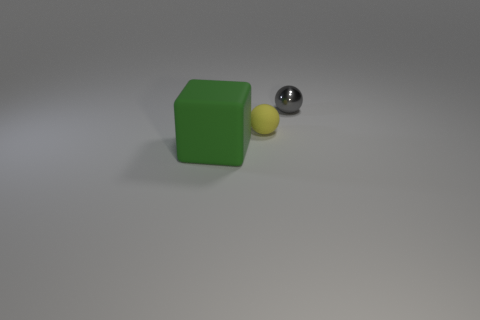The other object that is the same material as the small yellow thing is what size?
Your answer should be very brief. Large. There is a object that is behind the big green thing and left of the tiny gray ball; what shape is it?
Your answer should be compact. Sphere. There is a large rubber block; are there any gray metallic things right of it?
Your answer should be very brief. Yes. Are there any other things that have the same size as the block?
Your response must be concise. No. Is the small yellow object the same shape as the small gray metal object?
Offer a terse response. Yes. What is the size of the matte block left of the thing that is right of the rubber sphere?
Keep it short and to the point. Large. What color is the tiny shiny object that is the same shape as the small matte thing?
Keep it short and to the point. Gray. What number of big matte objects are the same color as the metal thing?
Your answer should be compact. 0. The metal sphere is what size?
Provide a short and direct response. Small. Do the yellow matte object and the metallic object have the same size?
Your answer should be very brief. Yes. 